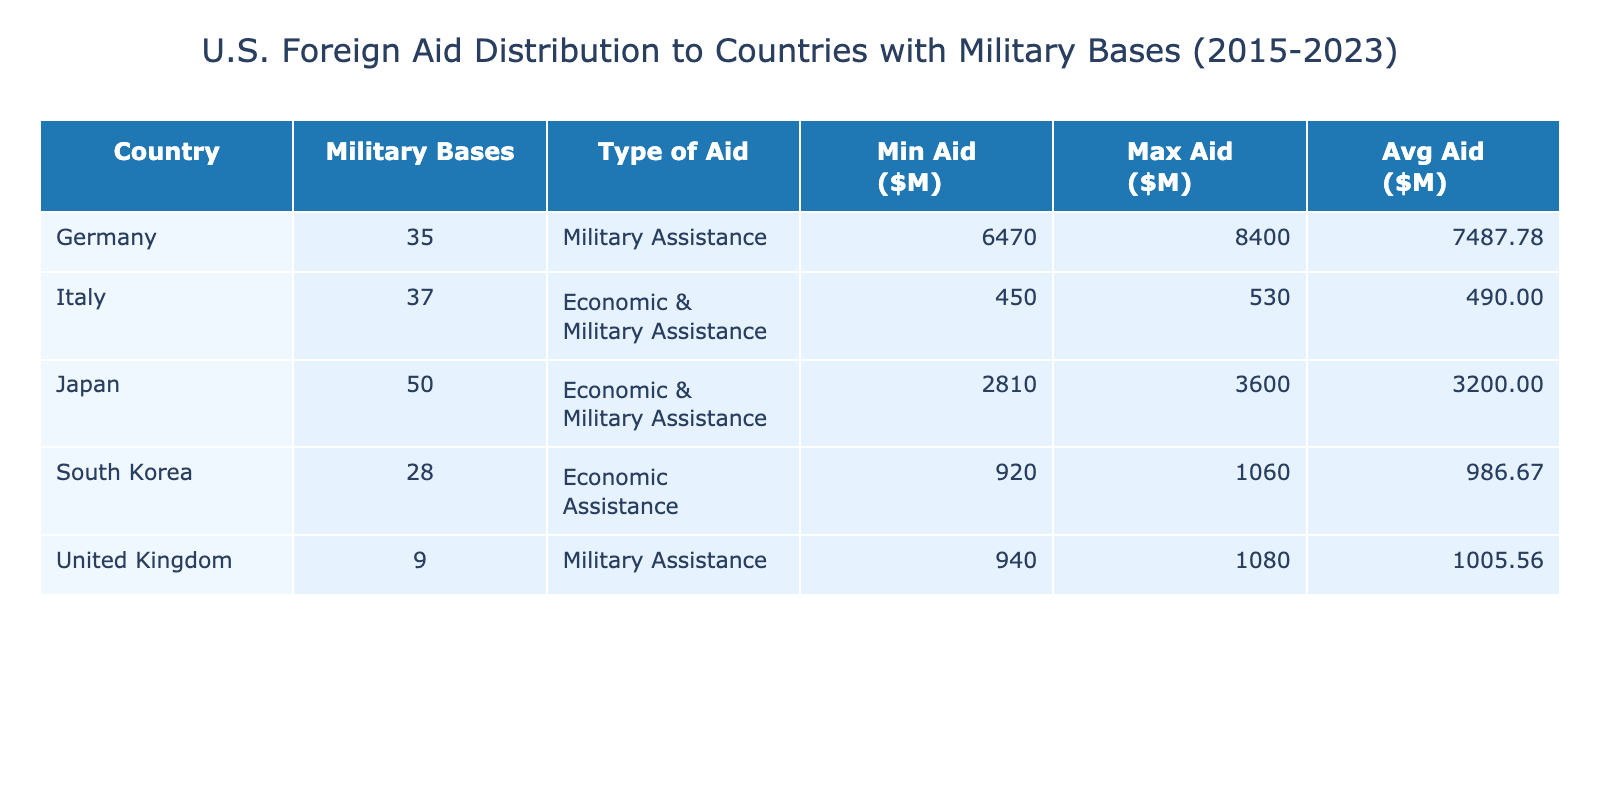What is the country with the highest average foreign aid? To find the country with the highest average foreign aid, we look at the 'Avg Aid' column. The values are: Germany: 7540.00, Japan: 3190.00, South Korea: 1000.00, United Kingdom: 1010.00, Italy: 485.00. The highest average is for Germany.
Answer: Germany What is the minimum foreign aid received by South Korea? To find the minimum foreign aid for South Korea, we check the 'Min Aid' column for South Korea, which shows a value of 920.
Answer: 920 Is it true that Japan received more foreign aid in 2023 than in 2015? We compare the foreign aid figures for Japan in 2015 (2810) and 2023 (3600). Since 3600 is greater than 2810, the statement is true.
Answer: Yes What is the total foreign aid distributed to Italy over the years? To find the total foreign aid to Italy, we sum up the foreign aid values from each year: (450 + 460 + 470 + 480 + 490 + 500 + 510 + 520 + 530) = 3920.
Answer: 3920 Which country received the least foreign aid on average, and what is that average? We compare the average foreign aid values: Germany: 7540.00, Japan: 3190.00, South Korea: 1000.00, United Kingdom: 1010.00, Italy: 485.00. The least is Italy with 485.00.
Answer: Italy, 485.00 How much foreign aid did the United Kingdom receive in 2021? To find this, we look at the 'Foreign Aid ($ Millions)' for the United Kingdom in the year 2021, which is 1040.
Answer: 1040 What is the difference in maximum foreign aid received between Germany and South Korea? The maximum foreign aid for Germany is 8400, and for South Korea, it is 1060. We calculate the difference: 8400 - 1060 = 7340.
Answer: 7340 Has the average foreign aid for Germany increased from 2015 to 2023? The average foreign aid for Germany in 2015 was 6470 and in 2023 was 8400. Since 8400 is greater than 6470, the average has increased.
Answer: Yes What type of aid is primarily given to the United Kingdom? We look at the 'Type of Aid' column for the United Kingdom and see it is classified as 'Military Assistance'.
Answer: Military Assistance 